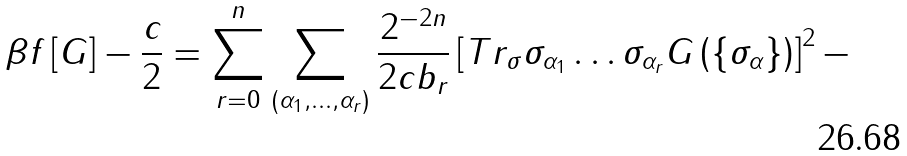Convert formula to latex. <formula><loc_0><loc_0><loc_500><loc_500>\beta f \left [ G \right ] - \frac { c } { 2 } = \sum _ { r = 0 } ^ { n } \sum _ { \left ( \alpha _ { 1 } , \dots , \alpha _ { r } \right ) } \frac { 2 ^ { - 2 n } } { 2 c b _ { r } } \left [ T r _ { \sigma } \sigma _ { \alpha _ { 1 } } \dots \sigma _ { \alpha _ { r } } G \left ( \left \{ \sigma _ { \alpha } \right \} \right ) \right ] ^ { 2 } -</formula> 